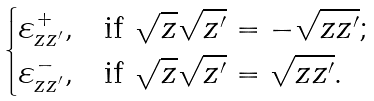Convert formula to latex. <formula><loc_0><loc_0><loc_500><loc_500>\begin{cases} \varepsilon _ { z z ^ { \prime } } ^ { + } , & \text {if $\sqrt{z}\sqrt{z^{\prime}}=-\sqrt{zz^{\prime}}$;} \\ \varepsilon _ { z z ^ { \prime } } ^ { - } , & \text {if $\sqrt{z}\sqrt{z^{\prime}}=\sqrt{zz^{\prime}}$.} \end{cases}</formula> 